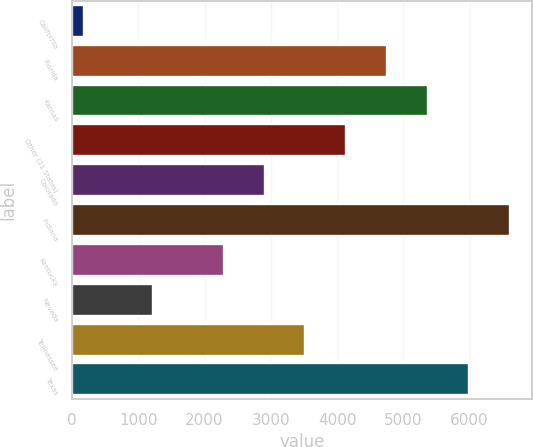Convert chart. <chart><loc_0><loc_0><loc_500><loc_500><bar_chart><fcel>California<fcel>Florida<fcel>Kansas<fcel>Other (21 States)<fcel>Colorado<fcel>Indiana<fcel>Kentucky<fcel>Nevada<fcel>Tennessee<fcel>Texas<nl><fcel>180<fcel>4757<fcel>5374<fcel>4140<fcel>2906<fcel>6608<fcel>2289<fcel>1216<fcel>3523<fcel>5991<nl></chart> 